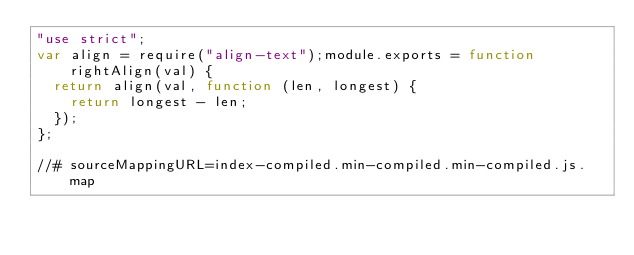<code> <loc_0><loc_0><loc_500><loc_500><_JavaScript_>"use strict";
var align = require("align-text");module.exports = function rightAlign(val) {
  return align(val, function (len, longest) {
    return longest - len;
  });
};

//# sourceMappingURL=index-compiled.min-compiled.min-compiled.js.map</code> 